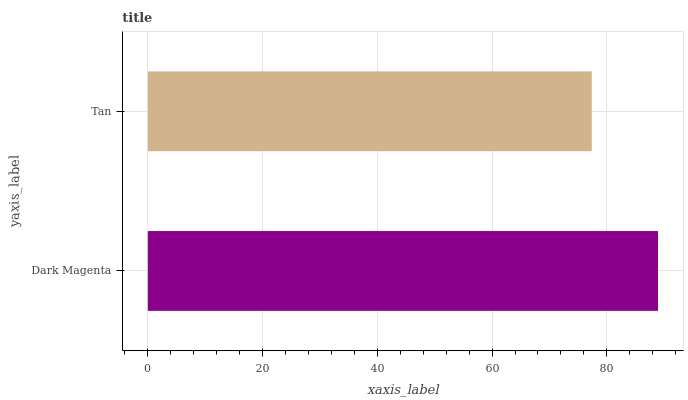Is Tan the minimum?
Answer yes or no. Yes. Is Dark Magenta the maximum?
Answer yes or no. Yes. Is Tan the maximum?
Answer yes or no. No. Is Dark Magenta greater than Tan?
Answer yes or no. Yes. Is Tan less than Dark Magenta?
Answer yes or no. Yes. Is Tan greater than Dark Magenta?
Answer yes or no. No. Is Dark Magenta less than Tan?
Answer yes or no. No. Is Dark Magenta the high median?
Answer yes or no. Yes. Is Tan the low median?
Answer yes or no. Yes. Is Tan the high median?
Answer yes or no. No. Is Dark Magenta the low median?
Answer yes or no. No. 